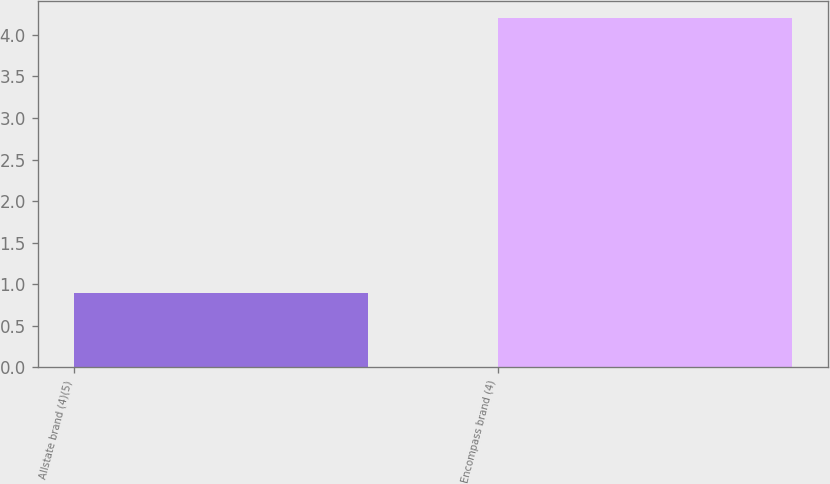Convert chart to OTSL. <chart><loc_0><loc_0><loc_500><loc_500><bar_chart><fcel>Allstate brand (4)(5)<fcel>Encompass brand (4)<nl><fcel>0.9<fcel>4.2<nl></chart> 